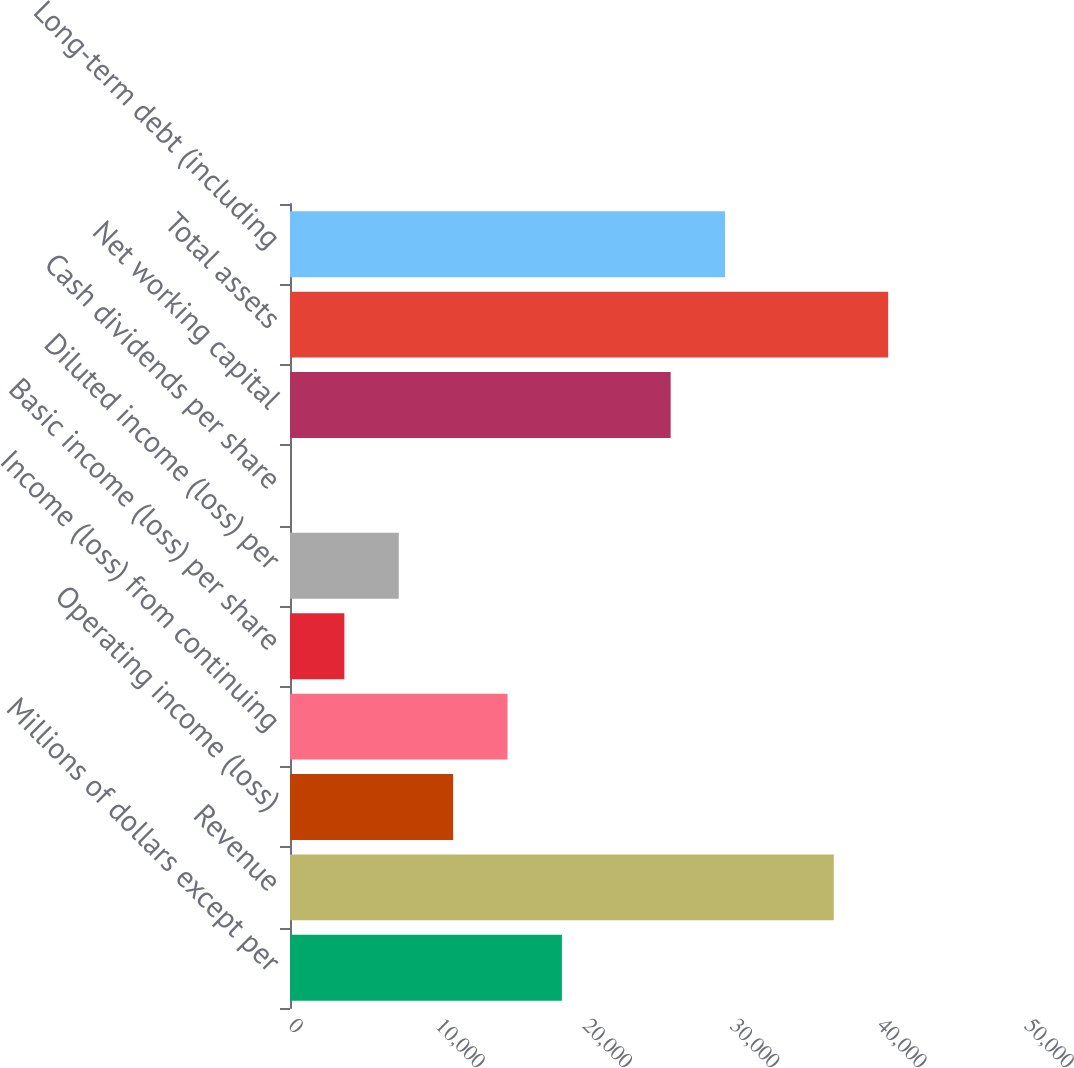<chart> <loc_0><loc_0><loc_500><loc_500><bar_chart><fcel>Millions of dollars except per<fcel>Revenue<fcel>Operating income (loss)<fcel>Income (loss) from continuing<fcel>Basic income (loss) per share<fcel>Diluted income (loss) per<fcel>Cash dividends per share<fcel>Net working capital<fcel>Total assets<fcel>Long-term debt (including<nl><fcel>18471.4<fcel>36942<fcel>11083.1<fcel>14777.2<fcel>3694.85<fcel>7388.98<fcel>0.72<fcel>25859.6<fcel>40636.2<fcel>29553.8<nl></chart> 